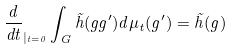Convert formula to latex. <formula><loc_0><loc_0><loc_500><loc_500>\frac { d } { d t } _ { | _ { t = 0 } } \int _ { G } \tilde { h } ( g g ^ { \prime } ) d \mu _ { t } ( g ^ { \prime } ) = \tilde { h } ( g )</formula> 